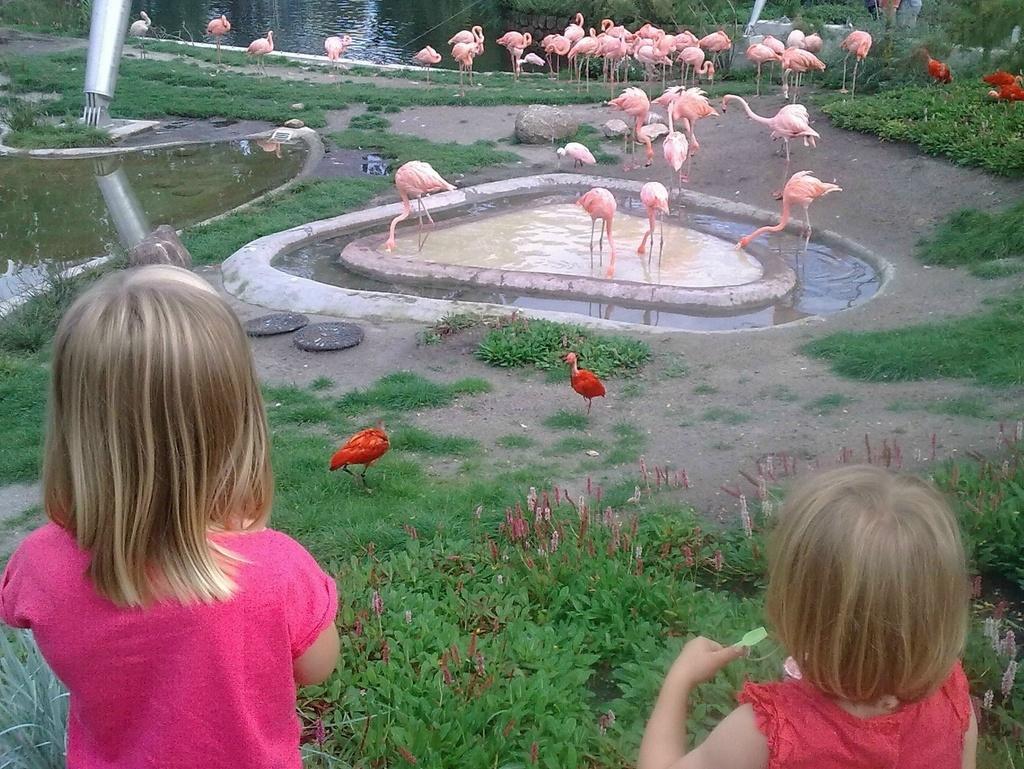Could you give a brief overview of what you see in this image? In this image we can see two children standing. We can also see some plants, grass, a group of birds, the water, stones, a pole and some trees. 